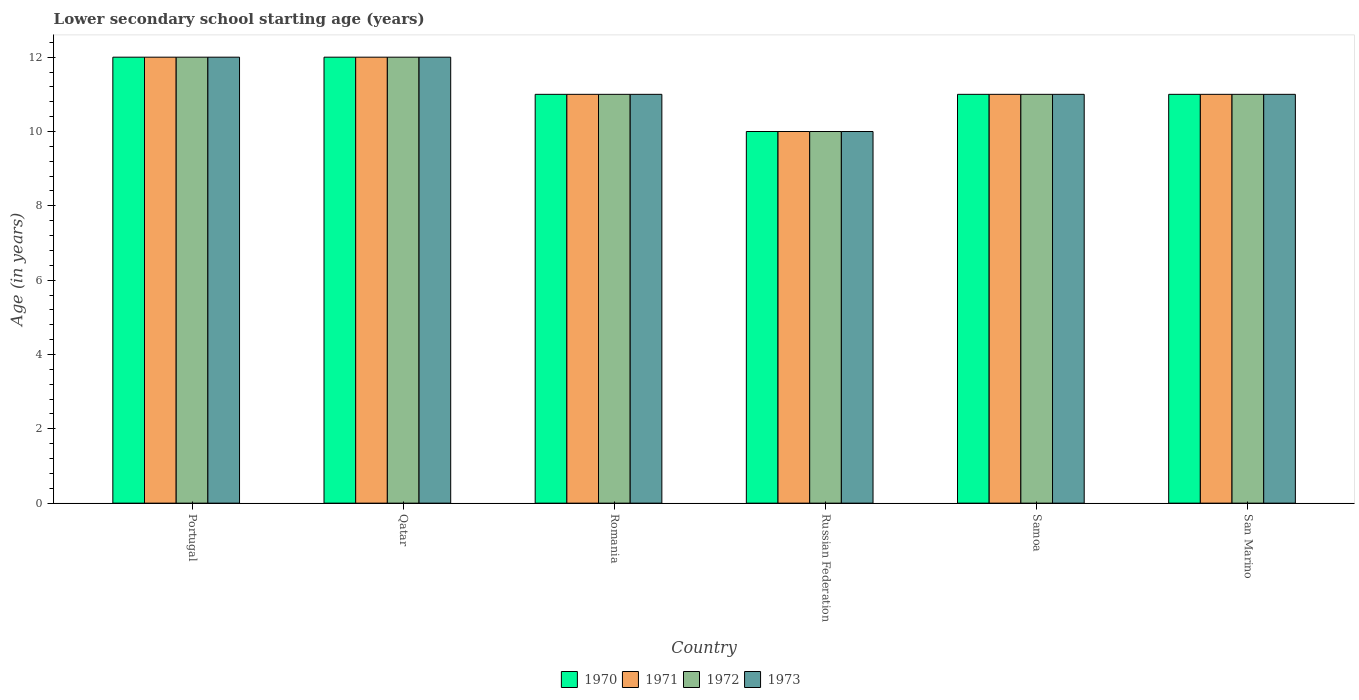Are the number of bars per tick equal to the number of legend labels?
Offer a terse response. Yes. How many bars are there on the 2nd tick from the left?
Your answer should be very brief. 4. How many bars are there on the 4th tick from the right?
Provide a short and direct response. 4. What is the label of the 2nd group of bars from the left?
Your response must be concise. Qatar. What is the lower secondary school starting age of children in 1972 in Samoa?
Make the answer very short. 11. In which country was the lower secondary school starting age of children in 1971 minimum?
Your response must be concise. Russian Federation. What is the total lower secondary school starting age of children in 1972 in the graph?
Ensure brevity in your answer.  67. What is the average lower secondary school starting age of children in 1970 per country?
Your answer should be compact. 11.17. In how many countries, is the lower secondary school starting age of children in 1971 greater than 8.8 years?
Offer a terse response. 6. What is the ratio of the lower secondary school starting age of children in 1970 in Portugal to that in Romania?
Your answer should be compact. 1.09. What is the difference between the highest and the second highest lower secondary school starting age of children in 1973?
Ensure brevity in your answer.  -1. What is the difference between the highest and the lowest lower secondary school starting age of children in 1972?
Make the answer very short. 2. Is the sum of the lower secondary school starting age of children in 1972 in Qatar and Russian Federation greater than the maximum lower secondary school starting age of children in 1973 across all countries?
Offer a very short reply. Yes. What does the 2nd bar from the left in Portugal represents?
Offer a terse response. 1971. How many bars are there?
Your response must be concise. 24. Are all the bars in the graph horizontal?
Keep it short and to the point. No. How many countries are there in the graph?
Make the answer very short. 6. What is the difference between two consecutive major ticks on the Y-axis?
Offer a very short reply. 2. Where does the legend appear in the graph?
Give a very brief answer. Bottom center. What is the title of the graph?
Ensure brevity in your answer.  Lower secondary school starting age (years). Does "1987" appear as one of the legend labels in the graph?
Your answer should be very brief. No. What is the label or title of the X-axis?
Make the answer very short. Country. What is the label or title of the Y-axis?
Keep it short and to the point. Age (in years). What is the Age (in years) in 1971 in Portugal?
Give a very brief answer. 12. What is the Age (in years) of 1970 in Qatar?
Provide a short and direct response. 12. What is the Age (in years) of 1973 in Qatar?
Your response must be concise. 12. What is the Age (in years) in 1972 in Romania?
Offer a very short reply. 11. What is the Age (in years) of 1973 in Romania?
Ensure brevity in your answer.  11. What is the Age (in years) of 1970 in Samoa?
Give a very brief answer. 11. What is the Age (in years) in 1973 in Samoa?
Offer a terse response. 11. What is the Age (in years) in 1973 in San Marino?
Offer a very short reply. 11. Across all countries, what is the maximum Age (in years) of 1970?
Offer a terse response. 12. Across all countries, what is the minimum Age (in years) in 1970?
Offer a terse response. 10. Across all countries, what is the minimum Age (in years) in 1972?
Your answer should be compact. 10. Across all countries, what is the minimum Age (in years) of 1973?
Your answer should be very brief. 10. What is the total Age (in years) of 1971 in the graph?
Your response must be concise. 67. What is the total Age (in years) of 1972 in the graph?
Your answer should be very brief. 67. What is the total Age (in years) of 1973 in the graph?
Your answer should be compact. 67. What is the difference between the Age (in years) of 1971 in Portugal and that in Qatar?
Make the answer very short. 0. What is the difference between the Age (in years) of 1972 in Portugal and that in Qatar?
Ensure brevity in your answer.  0. What is the difference between the Age (in years) in 1971 in Portugal and that in Romania?
Offer a very short reply. 1. What is the difference between the Age (in years) of 1970 in Portugal and that in Russian Federation?
Keep it short and to the point. 2. What is the difference between the Age (in years) of 1972 in Portugal and that in Russian Federation?
Offer a terse response. 2. What is the difference between the Age (in years) in 1973 in Portugal and that in Russian Federation?
Your answer should be very brief. 2. What is the difference between the Age (in years) of 1972 in Portugal and that in Samoa?
Your response must be concise. 1. What is the difference between the Age (in years) in 1973 in Portugal and that in Samoa?
Offer a terse response. 1. What is the difference between the Age (in years) in 1970 in Portugal and that in San Marino?
Your answer should be compact. 1. What is the difference between the Age (in years) of 1972 in Portugal and that in San Marino?
Provide a succinct answer. 1. What is the difference between the Age (in years) of 1973 in Qatar and that in Romania?
Your response must be concise. 1. What is the difference between the Age (in years) of 1972 in Qatar and that in Russian Federation?
Make the answer very short. 2. What is the difference between the Age (in years) of 1973 in Qatar and that in Samoa?
Provide a short and direct response. 1. What is the difference between the Age (in years) in 1972 in Qatar and that in San Marino?
Your answer should be very brief. 1. What is the difference between the Age (in years) in 1970 in Romania and that in Russian Federation?
Offer a terse response. 1. What is the difference between the Age (in years) in 1973 in Romania and that in Russian Federation?
Give a very brief answer. 1. What is the difference between the Age (in years) in 1970 in Romania and that in Samoa?
Offer a very short reply. 0. What is the difference between the Age (in years) of 1972 in Romania and that in Samoa?
Your answer should be very brief. 0. What is the difference between the Age (in years) of 1973 in Romania and that in Samoa?
Make the answer very short. 0. What is the difference between the Age (in years) of 1971 in Romania and that in San Marino?
Your answer should be compact. 0. What is the difference between the Age (in years) in 1972 in Romania and that in San Marino?
Offer a terse response. 0. What is the difference between the Age (in years) of 1971 in Russian Federation and that in Samoa?
Offer a terse response. -1. What is the difference between the Age (in years) in 1970 in Russian Federation and that in San Marino?
Ensure brevity in your answer.  -1. What is the difference between the Age (in years) of 1973 in Russian Federation and that in San Marino?
Offer a very short reply. -1. What is the difference between the Age (in years) of 1971 in Portugal and the Age (in years) of 1972 in Qatar?
Make the answer very short. 0. What is the difference between the Age (in years) in 1972 in Portugal and the Age (in years) in 1973 in Qatar?
Ensure brevity in your answer.  0. What is the difference between the Age (in years) in 1970 in Portugal and the Age (in years) in 1973 in Romania?
Keep it short and to the point. 1. What is the difference between the Age (in years) in 1970 in Portugal and the Age (in years) in 1971 in Russian Federation?
Provide a short and direct response. 2. What is the difference between the Age (in years) in 1970 in Portugal and the Age (in years) in 1973 in Russian Federation?
Your response must be concise. 2. What is the difference between the Age (in years) in 1971 in Portugal and the Age (in years) in 1972 in Russian Federation?
Offer a terse response. 2. What is the difference between the Age (in years) of 1972 in Portugal and the Age (in years) of 1973 in Russian Federation?
Your response must be concise. 2. What is the difference between the Age (in years) in 1970 in Portugal and the Age (in years) in 1971 in Samoa?
Provide a succinct answer. 1. What is the difference between the Age (in years) of 1971 in Portugal and the Age (in years) of 1972 in Samoa?
Provide a short and direct response. 1. What is the difference between the Age (in years) of 1971 in Portugal and the Age (in years) of 1973 in Samoa?
Ensure brevity in your answer.  1. What is the difference between the Age (in years) of 1972 in Portugal and the Age (in years) of 1973 in Samoa?
Offer a terse response. 1. What is the difference between the Age (in years) in 1970 in Portugal and the Age (in years) in 1971 in San Marino?
Keep it short and to the point. 1. What is the difference between the Age (in years) in 1970 in Portugal and the Age (in years) in 1972 in San Marino?
Your response must be concise. 1. What is the difference between the Age (in years) in 1971 in Portugal and the Age (in years) in 1972 in San Marino?
Provide a short and direct response. 1. What is the difference between the Age (in years) of 1970 in Qatar and the Age (in years) of 1972 in Romania?
Your response must be concise. 1. What is the difference between the Age (in years) in 1971 in Qatar and the Age (in years) in 1973 in Romania?
Your response must be concise. 1. What is the difference between the Age (in years) in 1972 in Qatar and the Age (in years) in 1973 in Romania?
Make the answer very short. 1. What is the difference between the Age (in years) in 1970 in Qatar and the Age (in years) in 1972 in Russian Federation?
Offer a very short reply. 2. What is the difference between the Age (in years) of 1970 in Qatar and the Age (in years) of 1973 in Russian Federation?
Provide a succinct answer. 2. What is the difference between the Age (in years) of 1971 in Qatar and the Age (in years) of 1973 in Russian Federation?
Offer a terse response. 2. What is the difference between the Age (in years) in 1970 in Qatar and the Age (in years) in 1971 in Samoa?
Provide a succinct answer. 1. What is the difference between the Age (in years) in 1970 in Qatar and the Age (in years) in 1973 in Samoa?
Make the answer very short. 1. What is the difference between the Age (in years) of 1970 in Qatar and the Age (in years) of 1971 in San Marino?
Make the answer very short. 1. What is the difference between the Age (in years) in 1970 in Qatar and the Age (in years) in 1972 in San Marino?
Your answer should be compact. 1. What is the difference between the Age (in years) in 1970 in Qatar and the Age (in years) in 1973 in San Marino?
Your answer should be compact. 1. What is the difference between the Age (in years) in 1971 in Qatar and the Age (in years) in 1972 in San Marino?
Offer a very short reply. 1. What is the difference between the Age (in years) in 1972 in Qatar and the Age (in years) in 1973 in San Marino?
Your response must be concise. 1. What is the difference between the Age (in years) of 1970 in Romania and the Age (in years) of 1971 in Russian Federation?
Provide a succinct answer. 1. What is the difference between the Age (in years) of 1971 in Romania and the Age (in years) of 1972 in Russian Federation?
Provide a succinct answer. 1. What is the difference between the Age (in years) in 1971 in Romania and the Age (in years) in 1973 in Russian Federation?
Offer a terse response. 1. What is the difference between the Age (in years) of 1972 in Romania and the Age (in years) of 1973 in Russian Federation?
Keep it short and to the point. 1. What is the difference between the Age (in years) of 1970 in Romania and the Age (in years) of 1971 in Samoa?
Your answer should be compact. 0. What is the difference between the Age (in years) in 1970 in Romania and the Age (in years) in 1973 in Samoa?
Offer a very short reply. 0. What is the difference between the Age (in years) in 1971 in Romania and the Age (in years) in 1972 in Samoa?
Ensure brevity in your answer.  0. What is the difference between the Age (in years) of 1971 in Romania and the Age (in years) of 1973 in Samoa?
Ensure brevity in your answer.  0. What is the difference between the Age (in years) in 1972 in Romania and the Age (in years) in 1973 in Samoa?
Your response must be concise. 0. What is the difference between the Age (in years) of 1970 in Romania and the Age (in years) of 1971 in San Marino?
Your answer should be very brief. 0. What is the difference between the Age (in years) in 1971 in Romania and the Age (in years) in 1972 in San Marino?
Your response must be concise. 0. What is the difference between the Age (in years) in 1971 in Romania and the Age (in years) in 1973 in San Marino?
Your answer should be compact. 0. What is the difference between the Age (in years) of 1970 in Russian Federation and the Age (in years) of 1971 in Samoa?
Your answer should be compact. -1. What is the difference between the Age (in years) in 1970 in Russian Federation and the Age (in years) in 1973 in Samoa?
Your response must be concise. -1. What is the difference between the Age (in years) in 1971 in Russian Federation and the Age (in years) in 1973 in Samoa?
Provide a succinct answer. -1. What is the difference between the Age (in years) of 1972 in Russian Federation and the Age (in years) of 1973 in Samoa?
Give a very brief answer. -1. What is the difference between the Age (in years) in 1970 in Russian Federation and the Age (in years) in 1971 in San Marino?
Your response must be concise. -1. What is the difference between the Age (in years) of 1971 in Russian Federation and the Age (in years) of 1972 in San Marino?
Give a very brief answer. -1. What is the difference between the Age (in years) in 1971 in Russian Federation and the Age (in years) in 1973 in San Marino?
Make the answer very short. -1. What is the difference between the Age (in years) in 1972 in Russian Federation and the Age (in years) in 1973 in San Marino?
Offer a very short reply. -1. What is the difference between the Age (in years) in 1970 in Samoa and the Age (in years) in 1972 in San Marino?
Ensure brevity in your answer.  0. What is the difference between the Age (in years) of 1970 in Samoa and the Age (in years) of 1973 in San Marino?
Offer a terse response. 0. What is the difference between the Age (in years) in 1972 in Samoa and the Age (in years) in 1973 in San Marino?
Your answer should be compact. 0. What is the average Age (in years) in 1970 per country?
Give a very brief answer. 11.17. What is the average Age (in years) of 1971 per country?
Your response must be concise. 11.17. What is the average Age (in years) of 1972 per country?
Give a very brief answer. 11.17. What is the average Age (in years) in 1973 per country?
Your answer should be very brief. 11.17. What is the difference between the Age (in years) in 1971 and Age (in years) in 1973 in Portugal?
Offer a terse response. 0. What is the difference between the Age (in years) of 1972 and Age (in years) of 1973 in Portugal?
Offer a terse response. 0. What is the difference between the Age (in years) in 1970 and Age (in years) in 1972 in Qatar?
Your response must be concise. 0. What is the difference between the Age (in years) in 1971 and Age (in years) in 1972 in Qatar?
Make the answer very short. 0. What is the difference between the Age (in years) in 1971 and Age (in years) in 1973 in Romania?
Make the answer very short. 0. What is the difference between the Age (in years) in 1972 and Age (in years) in 1973 in Romania?
Offer a very short reply. 0. What is the difference between the Age (in years) in 1970 and Age (in years) in 1971 in Russian Federation?
Keep it short and to the point. 0. What is the difference between the Age (in years) in 1970 and Age (in years) in 1972 in Russian Federation?
Offer a very short reply. 0. What is the difference between the Age (in years) in 1970 and Age (in years) in 1973 in Russian Federation?
Offer a terse response. 0. What is the difference between the Age (in years) in 1971 and Age (in years) in 1972 in Russian Federation?
Your answer should be compact. 0. What is the difference between the Age (in years) of 1972 and Age (in years) of 1973 in Russian Federation?
Ensure brevity in your answer.  0. What is the difference between the Age (in years) in 1970 and Age (in years) in 1972 in Samoa?
Give a very brief answer. 0. What is the difference between the Age (in years) of 1970 and Age (in years) of 1973 in Samoa?
Ensure brevity in your answer.  0. What is the difference between the Age (in years) in 1970 and Age (in years) in 1971 in San Marino?
Offer a very short reply. 0. What is the difference between the Age (in years) in 1970 and Age (in years) in 1972 in San Marino?
Offer a very short reply. 0. What is the difference between the Age (in years) of 1971 and Age (in years) of 1972 in San Marino?
Ensure brevity in your answer.  0. What is the ratio of the Age (in years) in 1971 in Portugal to that in Qatar?
Keep it short and to the point. 1. What is the ratio of the Age (in years) in 1973 in Portugal to that in Qatar?
Your answer should be very brief. 1. What is the ratio of the Age (in years) of 1972 in Portugal to that in Romania?
Offer a very short reply. 1.09. What is the ratio of the Age (in years) of 1971 in Portugal to that in Russian Federation?
Your response must be concise. 1.2. What is the ratio of the Age (in years) of 1970 in Portugal to that in Samoa?
Your answer should be compact. 1.09. What is the ratio of the Age (in years) in 1970 in Portugal to that in San Marino?
Offer a terse response. 1.09. What is the ratio of the Age (in years) of 1972 in Portugal to that in San Marino?
Provide a succinct answer. 1.09. What is the ratio of the Age (in years) in 1970 in Qatar to that in Romania?
Provide a succinct answer. 1.09. What is the ratio of the Age (in years) in 1972 in Qatar to that in Romania?
Give a very brief answer. 1.09. What is the ratio of the Age (in years) of 1973 in Qatar to that in Romania?
Your answer should be compact. 1.09. What is the ratio of the Age (in years) in 1970 in Qatar to that in Russian Federation?
Your response must be concise. 1.2. What is the ratio of the Age (in years) in 1971 in Qatar to that in Russian Federation?
Your answer should be compact. 1.2. What is the ratio of the Age (in years) in 1970 in Qatar to that in Samoa?
Offer a terse response. 1.09. What is the ratio of the Age (in years) of 1971 in Qatar to that in Samoa?
Your response must be concise. 1.09. What is the ratio of the Age (in years) of 1972 in Qatar to that in Samoa?
Give a very brief answer. 1.09. What is the ratio of the Age (in years) in 1970 in Qatar to that in San Marino?
Your answer should be compact. 1.09. What is the ratio of the Age (in years) in 1972 in Qatar to that in San Marino?
Provide a short and direct response. 1.09. What is the ratio of the Age (in years) in 1973 in Qatar to that in San Marino?
Give a very brief answer. 1.09. What is the ratio of the Age (in years) of 1970 in Romania to that in Russian Federation?
Provide a succinct answer. 1.1. What is the ratio of the Age (in years) in 1971 in Romania to that in Russian Federation?
Offer a very short reply. 1.1. What is the ratio of the Age (in years) in 1971 in Romania to that in San Marino?
Offer a terse response. 1. What is the ratio of the Age (in years) of 1973 in Romania to that in San Marino?
Your answer should be very brief. 1. What is the ratio of the Age (in years) of 1972 in Russian Federation to that in Samoa?
Offer a terse response. 0.91. What is the ratio of the Age (in years) in 1970 in Russian Federation to that in San Marino?
Your answer should be compact. 0.91. What is the ratio of the Age (in years) of 1971 in Russian Federation to that in San Marino?
Offer a very short reply. 0.91. What is the ratio of the Age (in years) of 1972 in Russian Federation to that in San Marino?
Offer a very short reply. 0.91. What is the ratio of the Age (in years) of 1973 in Russian Federation to that in San Marino?
Provide a succinct answer. 0.91. What is the ratio of the Age (in years) in 1972 in Samoa to that in San Marino?
Provide a succinct answer. 1. What is the ratio of the Age (in years) in 1973 in Samoa to that in San Marino?
Provide a succinct answer. 1. What is the difference between the highest and the second highest Age (in years) of 1970?
Your response must be concise. 0. What is the difference between the highest and the second highest Age (in years) in 1972?
Your response must be concise. 0. What is the difference between the highest and the second highest Age (in years) of 1973?
Make the answer very short. 0. What is the difference between the highest and the lowest Age (in years) of 1971?
Your response must be concise. 2. 